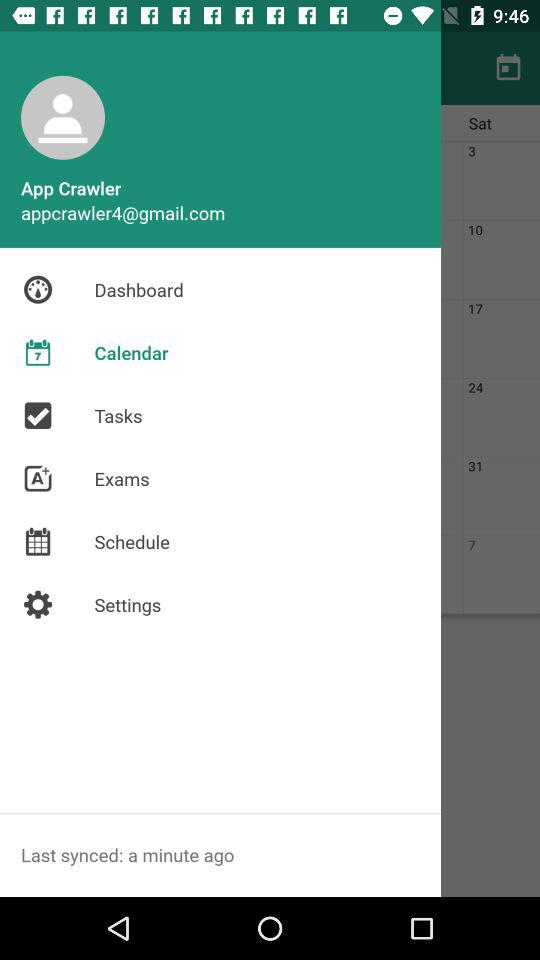What is the user name? The user name is App Crawler. 